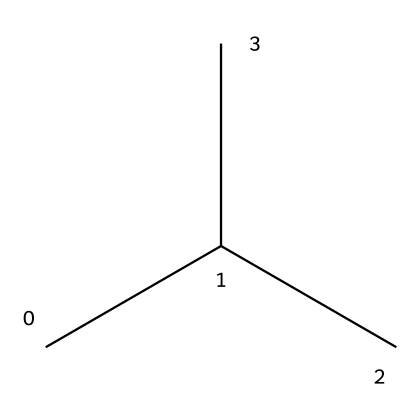What is the molecular formula of isobutane? Analyzing the SMILES representation (CC(C)C), we can count the carbon (C) and hydrogen (H) atoms. The carbon count is 4 and the hydrogen count is 10, leading to the molecular formula C4H10.
Answer: C4H10 How many carbon atoms are in isobutane? From the SMILES, CC(C)C indicates that there are four carbon atoms connected, which can be verified by counting the 'C' symbols.
Answer: 4 What type of hydrocarbon is isobutane? Isobutane is classified as an aliphatic hydrocarbon, which are characterized by their straight or branched chains of carbon atoms.
Answer: aliphatic Why is isobutane often used in aerosol sprays? Isobutane's properties, such as its low boiling point and ability to evaporate quickly, make it ideal for propellant use in aerosol sprays, particularly for special effects in film.
Answer: propellant How many hydrogen atoms are bonded to the central carbon in isobutane? Examining the structure, the central carbon is connected to three other carbon atoms and has no hydrogen directly bonded to it, meaning it has three hydrogen atoms attached to it instead of the typical four due to its branching.
Answer: 9 In the structure, what is the significance of the branching in isobutane compared to straight-chain alkanes? The branching of isobutane reduces the overall boiling point and increases its vapor pressure, making it more effective for use in aerosol applications compared to straight-chain alkanes with the same number of carbons.
Answer: effective 